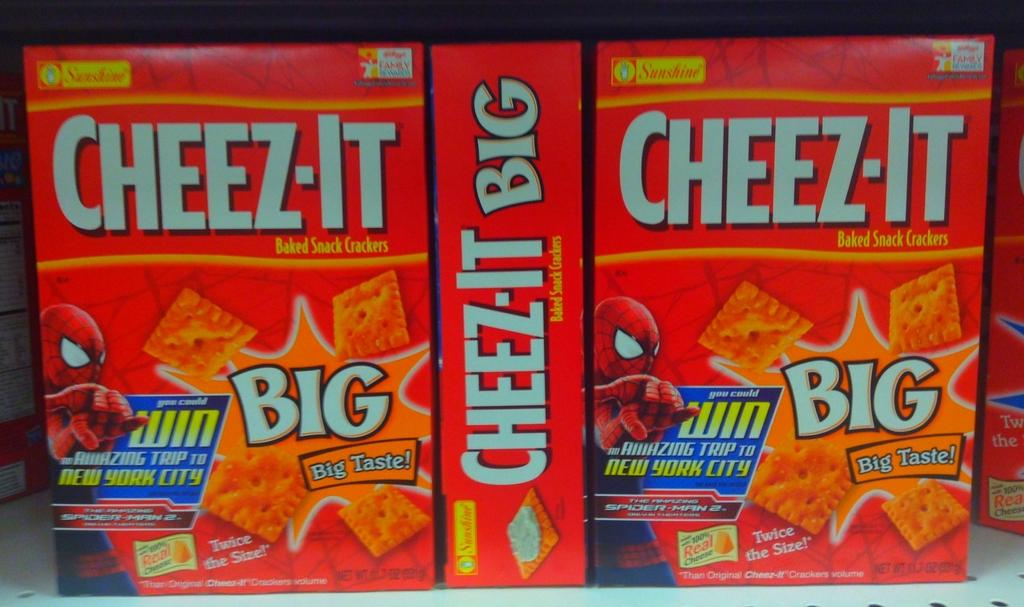What objects are present in the image? There are boxes in the image. How are the boxes arranged in the image? The boxes are in a white-colored rack. What color are the boxes? The boxes are red in color. Is there any text or markings on the boxes? Yes, there is writing on the boxes. Is there a letter being written in the image? There is no indication of a letter being written in the image. What type of current is flowing through the boxes in the image? There is no current present in the image; it features boxes in a white-colored rack. 